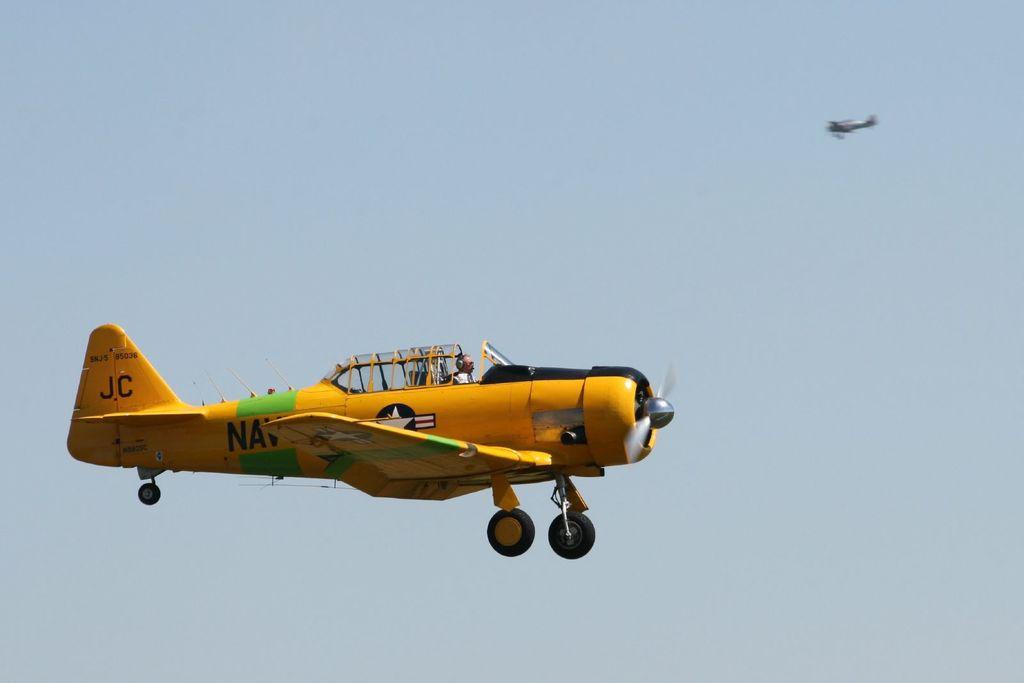What are the 3 letters printed between the cockpit and the tail?
Provide a succinct answer. Nav. What 2 letters are printed on the rear of the plane?
Provide a succinct answer. Jc. 